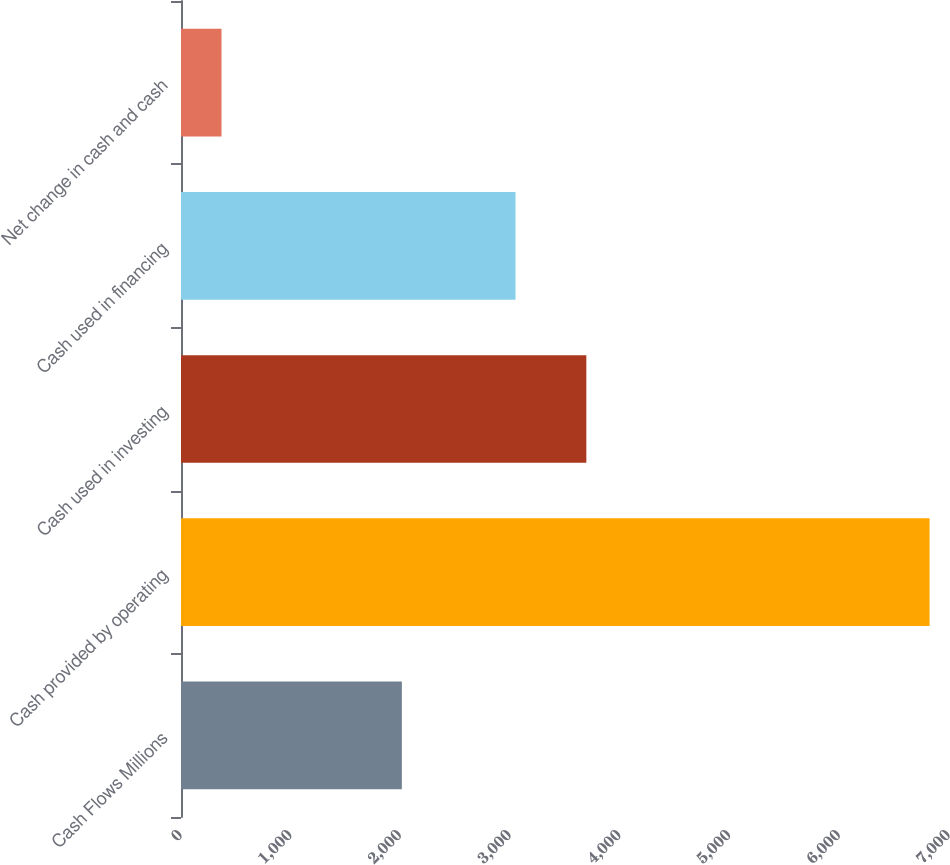<chart> <loc_0><loc_0><loc_500><loc_500><bar_chart><fcel>Cash Flows Millions<fcel>Cash provided by operating<fcel>Cash used in investing<fcel>Cash used in financing<fcel>Net change in cash and cash<nl><fcel>2013<fcel>6823<fcel>3694.4<fcel>3049<fcel>369<nl></chart> 